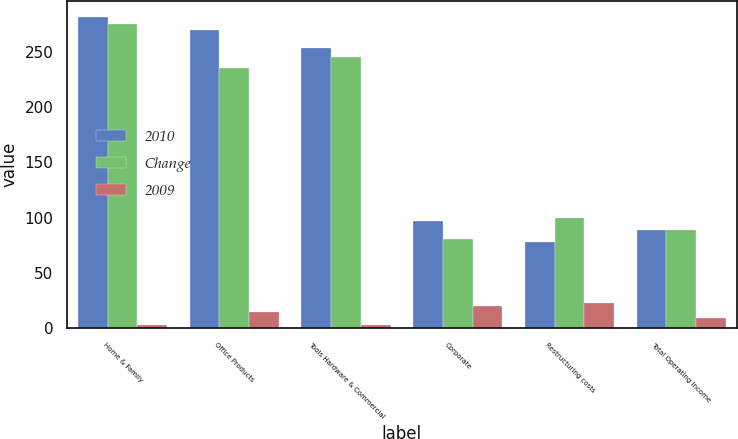Convert chart to OTSL. <chart><loc_0><loc_0><loc_500><loc_500><stacked_bar_chart><ecel><fcel>Home & Family<fcel>Office Products<fcel>Tools Hardware & Commercial<fcel>Corporate<fcel>Restructuring costs<fcel>Total Operating Income<nl><fcel>2010<fcel>281.8<fcel>269.4<fcel>253.1<fcel>96.9<fcel>77.5<fcel>88.75<nl><fcel>Change<fcel>274.7<fcel>235.2<fcel>245.6<fcel>80.6<fcel>100<fcel>88.75<nl><fcel>2009<fcel>2.6<fcel>14.5<fcel>3.1<fcel>20.2<fcel>22.5<fcel>9.6<nl></chart> 